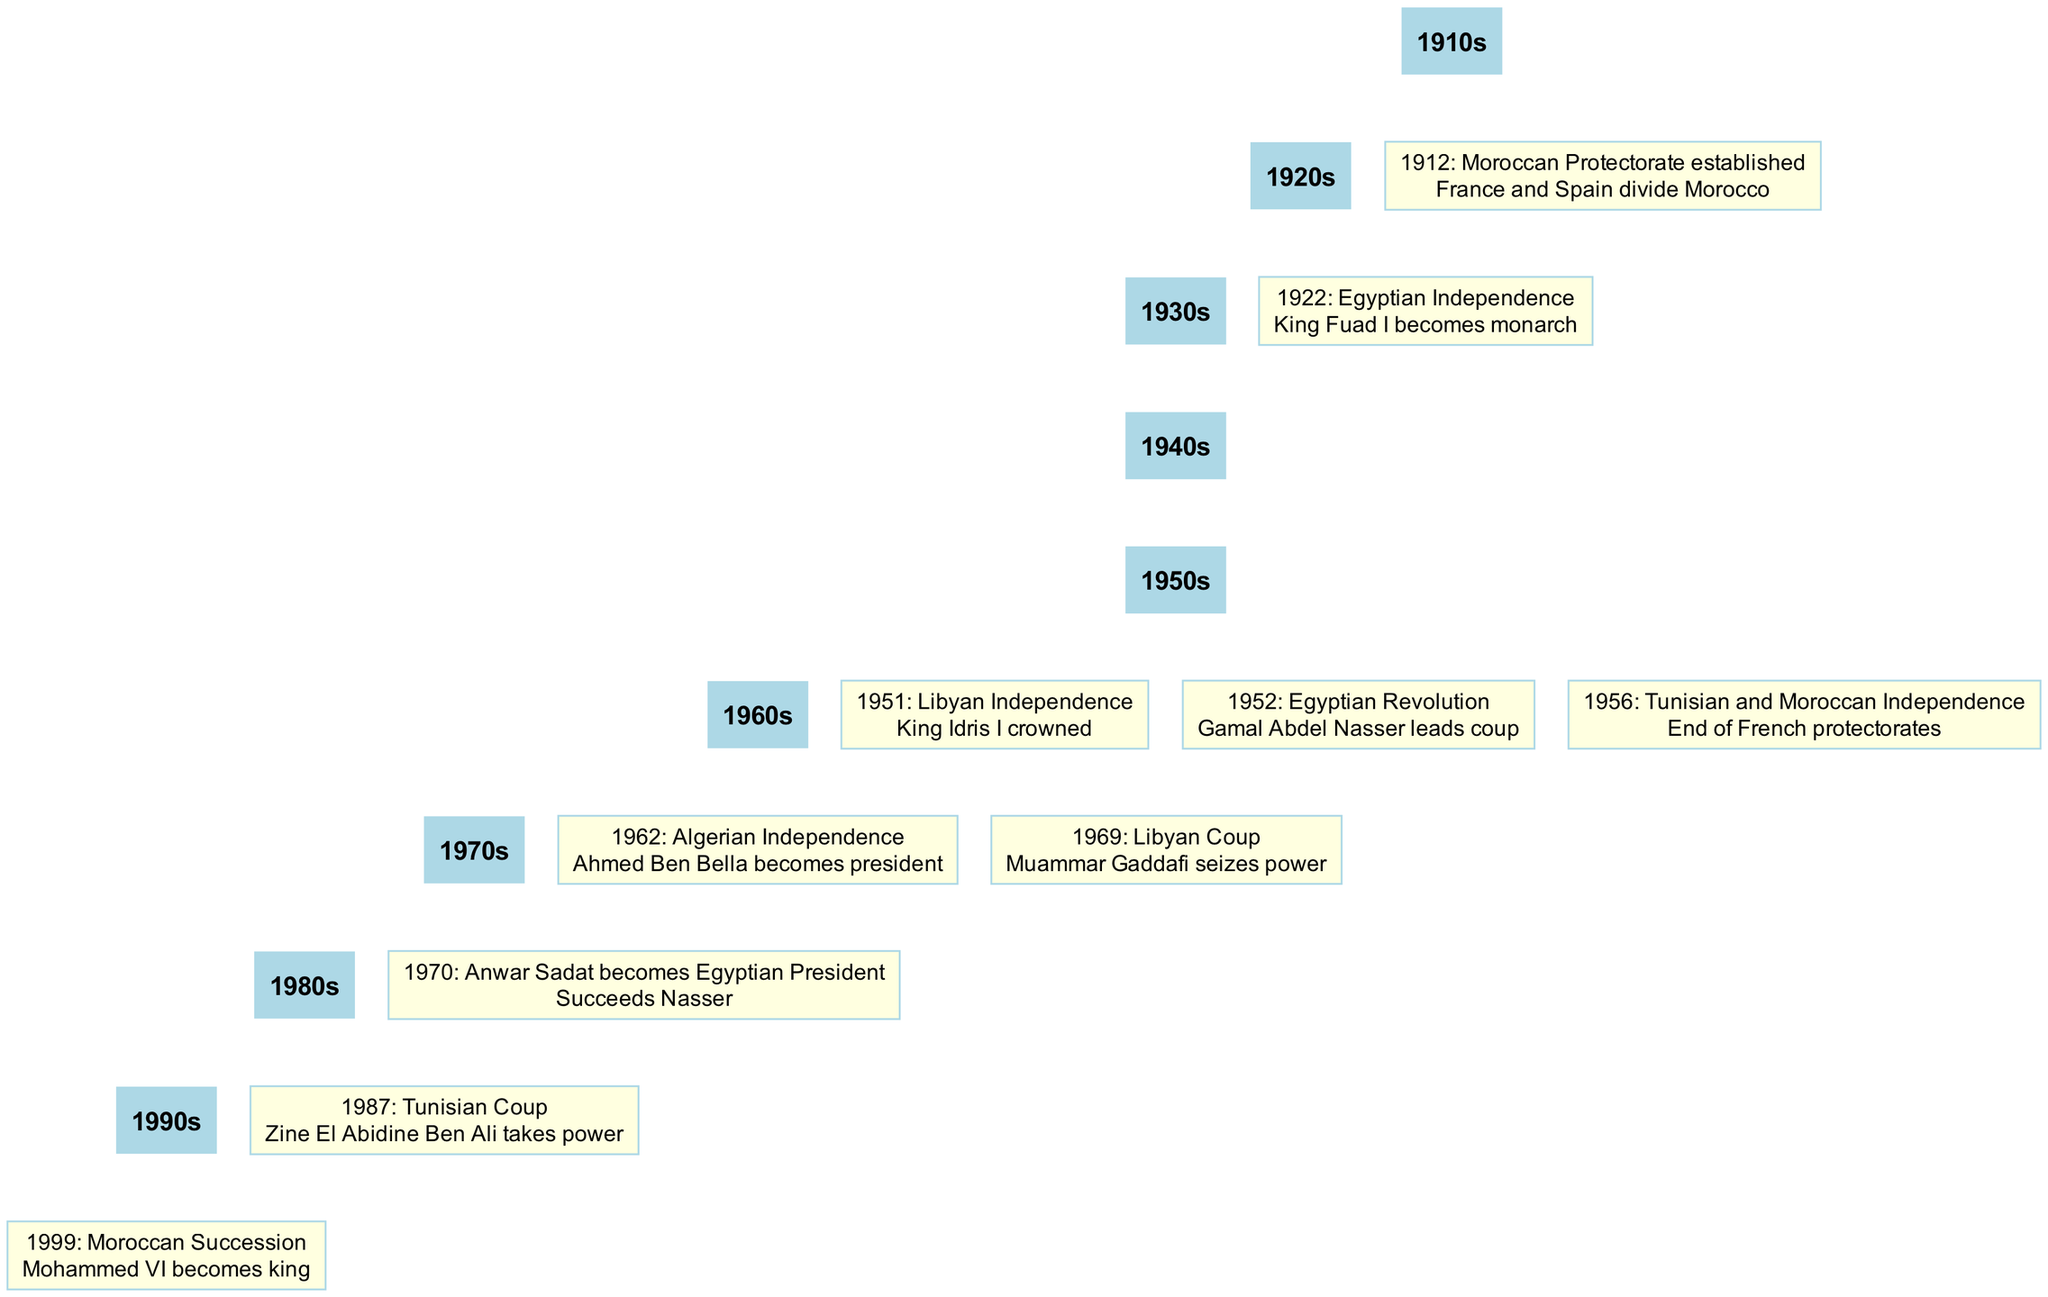What year was the Moroccan Protectorate established? The diagram shows that the event "Moroccan Protectorate established" took place in the year 1912. This is indicated by the timeline node associated with that event.
Answer: 1912 Who became President of Algeria in 1962? The event listed for the year 1962 shows "Ahmed Ben Bella becomes president." This indicates the key leadership change in Algeria during that year.
Answer: Ahmed Ben Bella Which event happened in 1952? Referring to the node for 1952 in the diagram, the event listed is "Egyptian Revolution." This event is significant and noted clearly in the timeline.
Answer: Egyptian Revolution How many total political events are listed in the timeline? By counting each event represented in the timeline from 1912 to 1999, there are a total of ten distinct political events included in the diagram.
Answer: 10 What is the relationship between the years 1956 and 1962 in the timeline? The diagram shows that the event in 1956, "Tunisian and Moroccan Independence," leads into the event in 1962, "Algerian Independence." This indicates a sequence of independence movements occurring in North Africa.
Answer: Sequence of independence What leader succeeded Gamal Abdel Nasser as Egyptian President? According to the diagram, the event for 1970 indicates "Anwar Sadat becomes Egyptian President," which provides the information about the successor of Nasser.
Answer: Anwar Sadat When did King Idris I become king? The diagram indicates that the event "Libyan Independence" in 1951 marks the ascendance of King Idris I, as specified in the details of that node.
Answer: 1951 Which two countries gained independence in 1956? The node for 1956 mentions "Tunisian and Moroccan Independence," thus denoting both countries that achieved independence during that year.
Answer: Tunisia and Morocco 